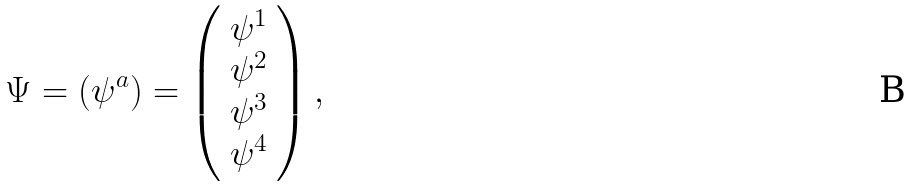<formula> <loc_0><loc_0><loc_500><loc_500>\Psi = ( \psi ^ { a } ) = \left ( \begin{array} { c } \psi ^ { 1 } \\ \psi ^ { 2 } \\ \psi ^ { 3 } \\ \psi ^ { 4 } \end{array} \right ) ,</formula> 